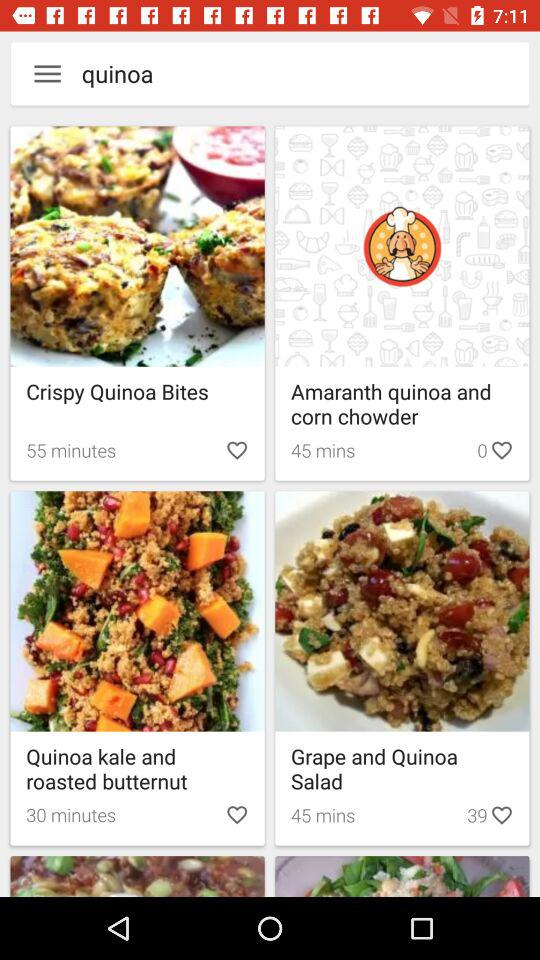How many items have a cooking time of 45 minutes?
Answer the question using a single word or phrase. 2 